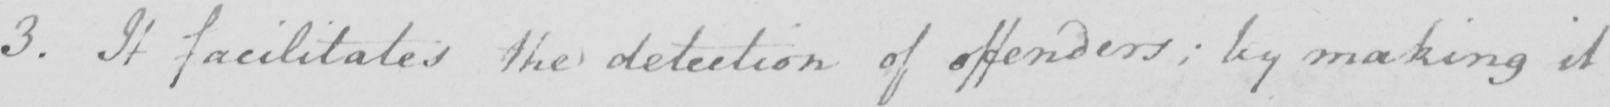Please provide the text content of this handwritten line. 3. It facilitates the detection of offenders; by making it 